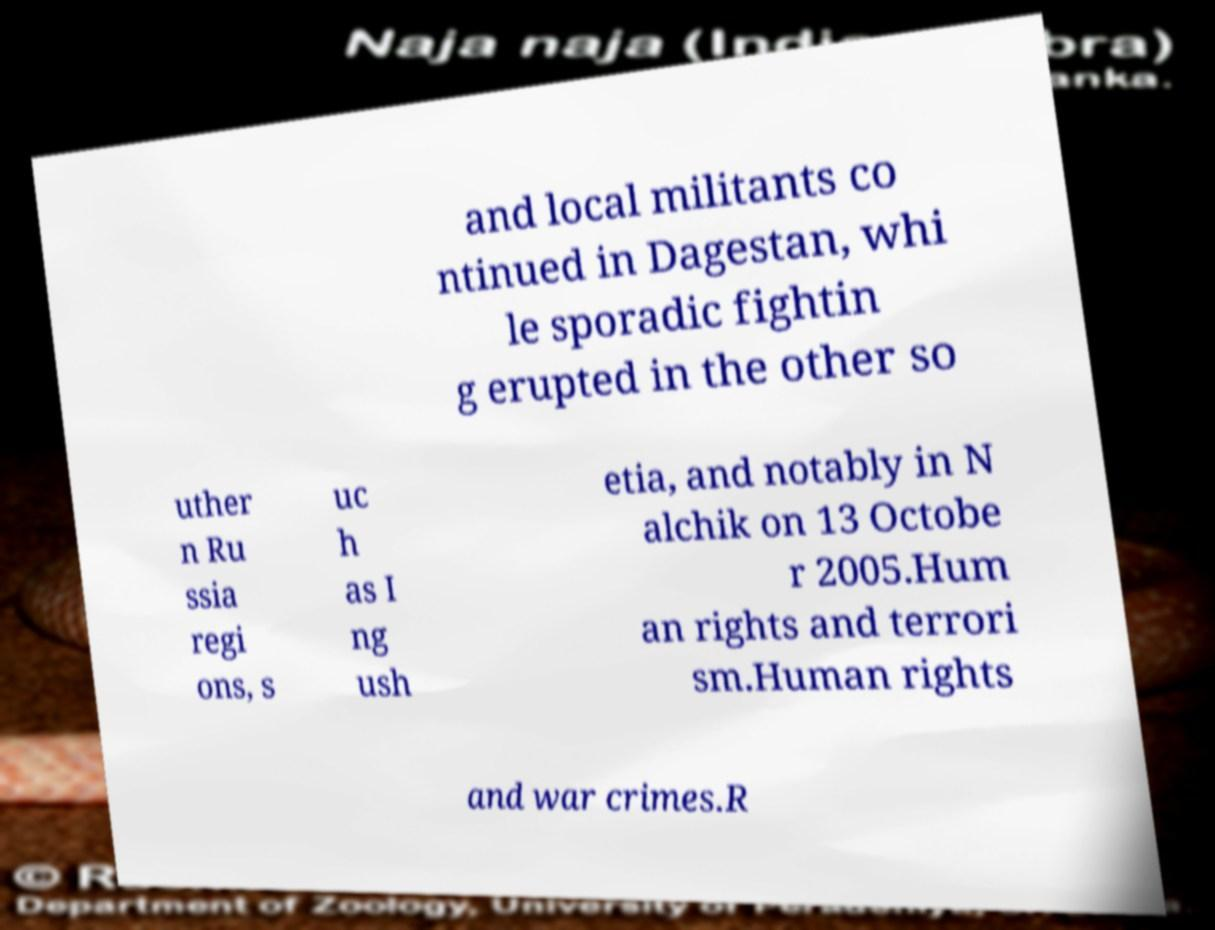Could you extract and type out the text from this image? and local militants co ntinued in Dagestan, whi le sporadic fightin g erupted in the other so uther n Ru ssia regi ons, s uc h as I ng ush etia, and notably in N alchik on 13 Octobe r 2005.Hum an rights and terrori sm.Human rights and war crimes.R 